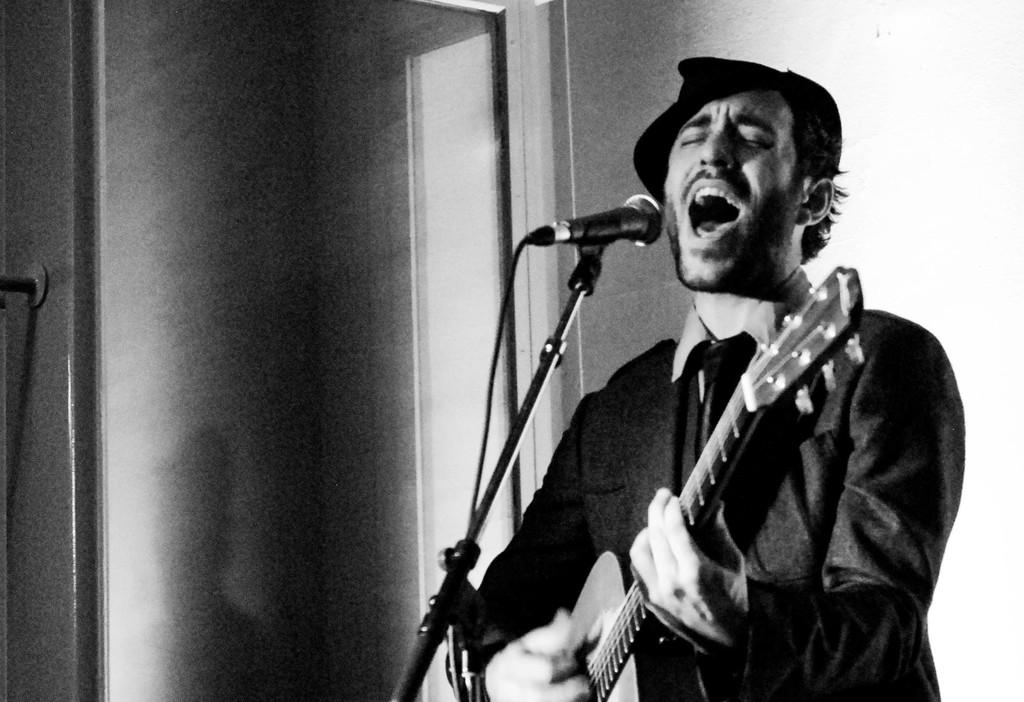What is the main subject of the image? There is a person in the image. What is the person doing in the image? The person is standing and playing a guitar. What can be seen behind the person? The person is in front of a mic. What type of chin can be seen on the person in the image? There is no specific chin mentioned or visible in the image; it is a general image of a person playing a guitar. Can you see any playground equipment in the image? There is no playground equipment present in the image. 